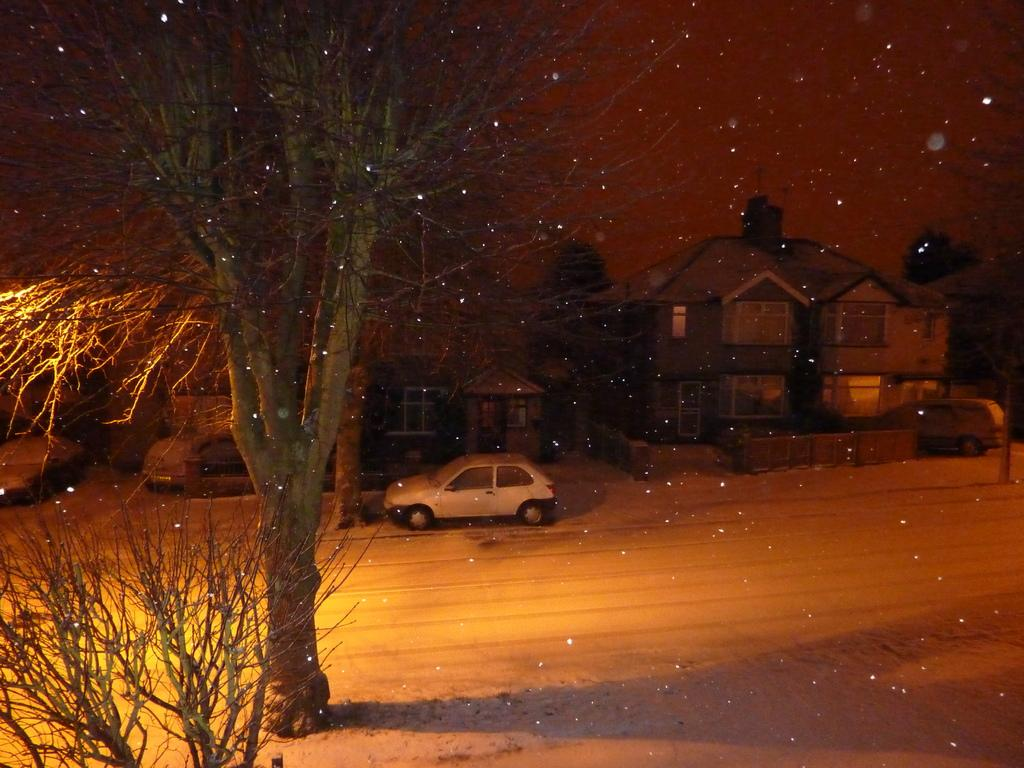What type of structures can be seen in the image? There are buildings in the image. What else is visible besides the buildings? There are vehicles and trees in the image. What is visible at the top of the image? The sky is visible at the top of the image. What is located at the bottom of the image? There is a road at the bottom of the image. How was the image created? The image is an edited picture. What type of curtain is hanging from the trees in the image? There are no curtains hanging from the trees in the image; it features buildings, vehicles, trees, and a road. How many clovers can be seen growing on the road in the image? There are no clovers present in the image; it features buildings, vehicles, trees, and a road. 